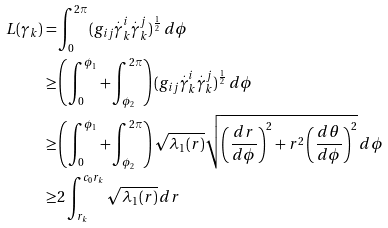Convert formula to latex. <formula><loc_0><loc_0><loc_500><loc_500>L ( \gamma _ { k } ) = & \int _ { 0 } ^ { 2 \pi } ( g _ { i j } \overset { . } \gamma _ { k } ^ { i } \overset { . } \gamma _ { k } ^ { j } ) ^ { \frac { 1 } { 2 } } \, d \phi \\ \geq & \left ( \int _ { 0 } ^ { \phi _ { 1 } } + \int _ { \phi _ { 2 } } ^ { 2 \pi } \right ) ( g _ { i j } \overset { . } \gamma _ { k } ^ { i } \overset { . } \gamma _ { k } ^ { j } ) ^ { \frac { 1 } { 2 } } \, d \phi \\ \geq & \left ( \int _ { 0 } ^ { \phi _ { 1 } } + \int _ { \phi _ { 2 } } ^ { 2 \pi } \right ) \sqrt { \lambda _ { 1 } ( r ) } \sqrt { \left ( \frac { d r } { d \phi } \right ) ^ { 2 } + r ^ { 2 } \left ( \frac { d \theta } { d \phi } \right ) ^ { 2 } } \, d \phi \\ \geq & 2 \int _ { r _ { k } } ^ { c _ { 0 } r _ { k } } \sqrt { \lambda _ { 1 } ( r ) } \, d r</formula> 